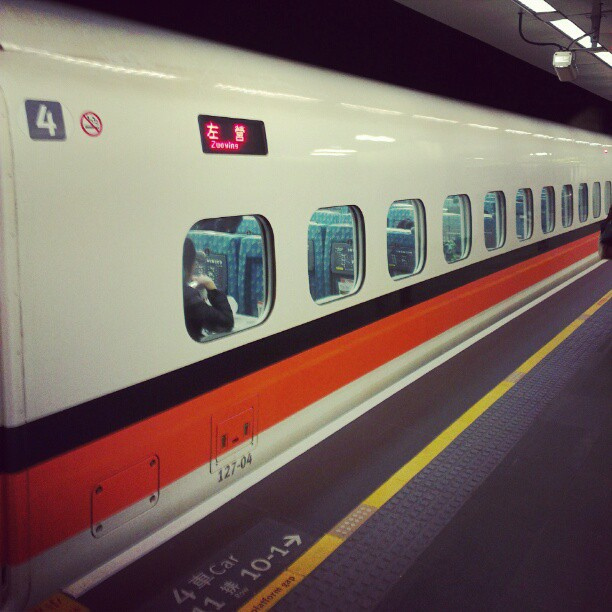Please identify all text content in this image. 10-1 